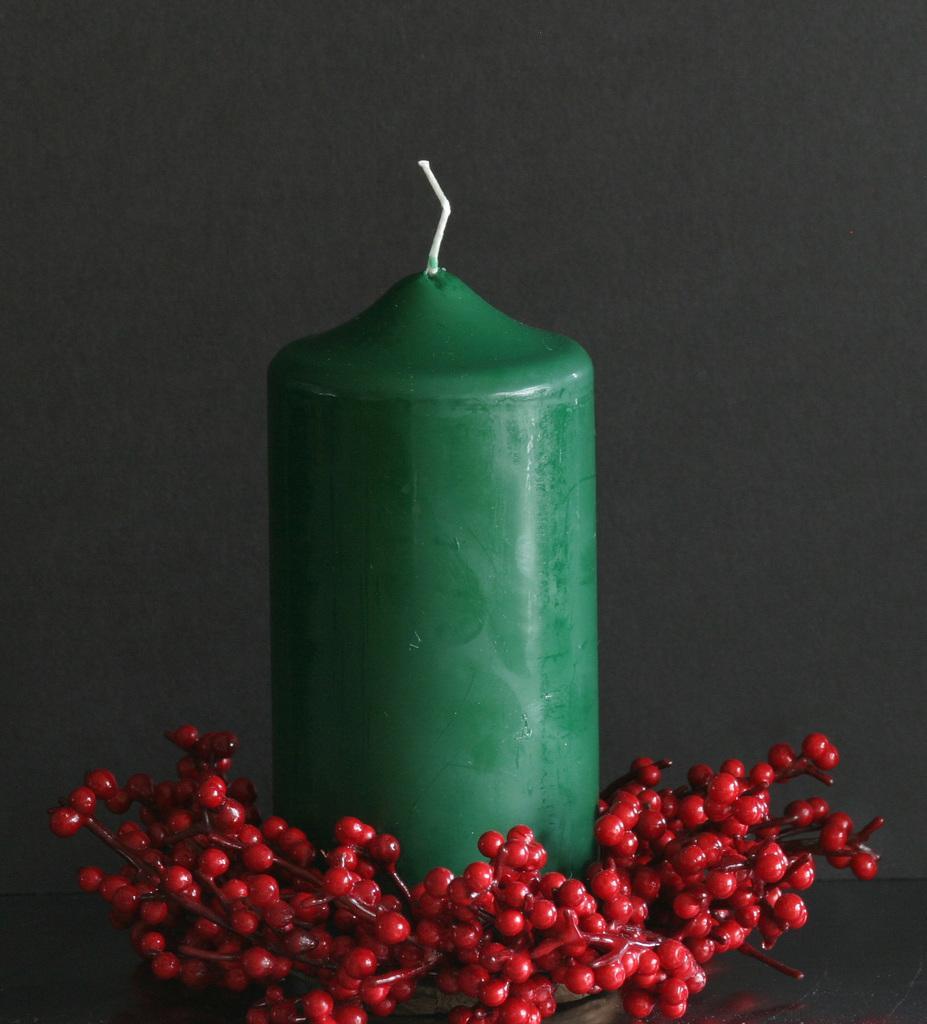Could you give a brief overview of what you see in this image? In this image there is a green colour candle. Before it there are few artificial fruits are on the table. Behind the candle there is wall. 